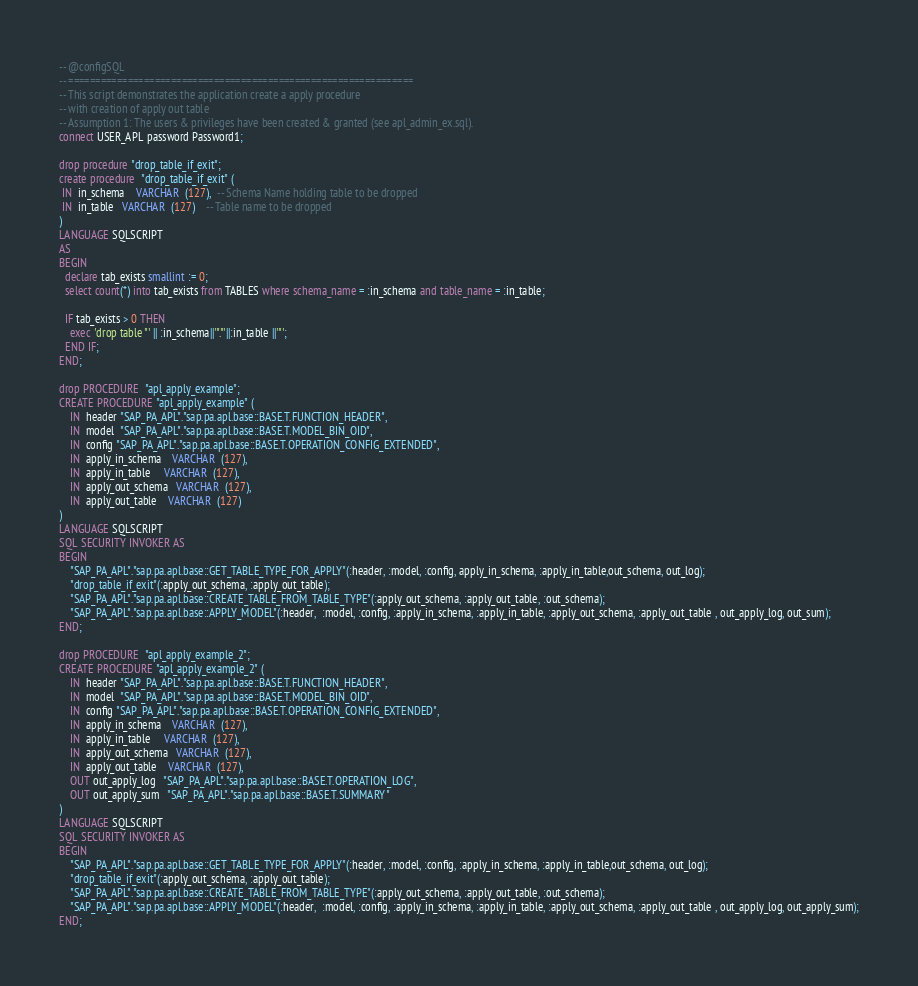<code> <loc_0><loc_0><loc_500><loc_500><_SQL_>-- @configSQL
-- ================================================================
-- This script demonstrates the application create a apply procedure 
-- with creation of apply out table
-- Assumption 1: The users & privileges have been created & granted (see apl_admin_ex.sql).
connect USER_APL password Password1;

drop procedure "drop_table_if_exit";
create procedure  "drop_table_if_exit" (
 IN  in_schema    VARCHAR  (127),  -- Schema Name holding table to be dropped
 IN  in_table   VARCHAR  (127)    -- Table name to be dropped
)
LANGUAGE SQLSCRIPT
AS
BEGIN
  declare tab_exists smallint := 0;
  select count(*) into tab_exists from TABLES where schema_name = :in_schema and table_name = :in_table;
  
  IF tab_exists > 0 THEN
    exec 'drop table "' || :in_schema||'"."'||:in_table ||'"';
  END IF;
END;

drop PROCEDURE  "apl_apply_example";
CREATE PROCEDURE "apl_apply_example" (
    IN  header "SAP_PA_APL"."sap.pa.apl.base::BASE.T.FUNCTION_HEADER",
    IN  model  "SAP_PA_APL"."sap.pa.apl.base::BASE.T.MODEL_BIN_OID",
    IN  config "SAP_PA_APL"."sap.pa.apl.base::BASE.T.OPERATION_CONFIG_EXTENDED",
    IN  apply_in_schema    VARCHAR  (127),
    IN  apply_in_table     VARCHAR  (127),
    IN  apply_out_schema   VARCHAR  (127),
    IN  apply_out_table    VARCHAR  (127)
)
LANGUAGE SQLSCRIPT
SQL SECURITY INVOKER AS
BEGIN
    "SAP_PA_APL"."sap.pa.apl.base::GET_TABLE_TYPE_FOR_APPLY"(:header, :model, :config, apply_in_schema, :apply_in_table,out_schema, out_log);
    "drop_table_if_exit"(:apply_out_schema, :apply_out_table);
    "SAP_PA_APL"."sap.pa.apl.base::CREATE_TABLE_FROM_TABLE_TYPE"(:apply_out_schema, :apply_out_table, :out_schema);
    "SAP_PA_APL"."sap.pa.apl.base::APPLY_MODEL"(:header,  :model, :config, :apply_in_schema, :apply_in_table, :apply_out_schema, :apply_out_table , out_apply_log, out_sum);
END;

drop PROCEDURE  "apl_apply_example_2";
CREATE PROCEDURE "apl_apply_example_2" (
    IN  header "SAP_PA_APL"."sap.pa.apl.base::BASE.T.FUNCTION_HEADER",
    IN  model  "SAP_PA_APL"."sap.pa.apl.base::BASE.T.MODEL_BIN_OID",
    IN  config "SAP_PA_APL"."sap.pa.apl.base::BASE.T.OPERATION_CONFIG_EXTENDED",
    IN  apply_in_schema    VARCHAR  (127),
    IN  apply_in_table     VARCHAR  (127),
    IN  apply_out_schema   VARCHAR  (127),
    IN  apply_out_table    VARCHAR  (127),
    OUT out_apply_log   "SAP_PA_APL"."sap.pa.apl.base::BASE.T.OPERATION_LOG",
    OUT out_apply_sum   "SAP_PA_APL"."sap.pa.apl.base::BASE.T.SUMMARY"
)
LANGUAGE SQLSCRIPT
SQL SECURITY INVOKER AS
BEGIN
    "SAP_PA_APL"."sap.pa.apl.base::GET_TABLE_TYPE_FOR_APPLY"(:header, :model, :config, :apply_in_schema, :apply_in_table,out_schema, out_log);
    "drop_table_if_exit"(:apply_out_schema, :apply_out_table);
    "SAP_PA_APL"."sap.pa.apl.base::CREATE_TABLE_FROM_TABLE_TYPE"(:apply_out_schema, :apply_out_table, :out_schema);
    "SAP_PA_APL"."sap.pa.apl.base::APPLY_MODEL"(:header,  :model, :config, :apply_in_schema, :apply_in_table, :apply_out_schema, :apply_out_table , out_apply_log, out_apply_sum);
END;
</code> 